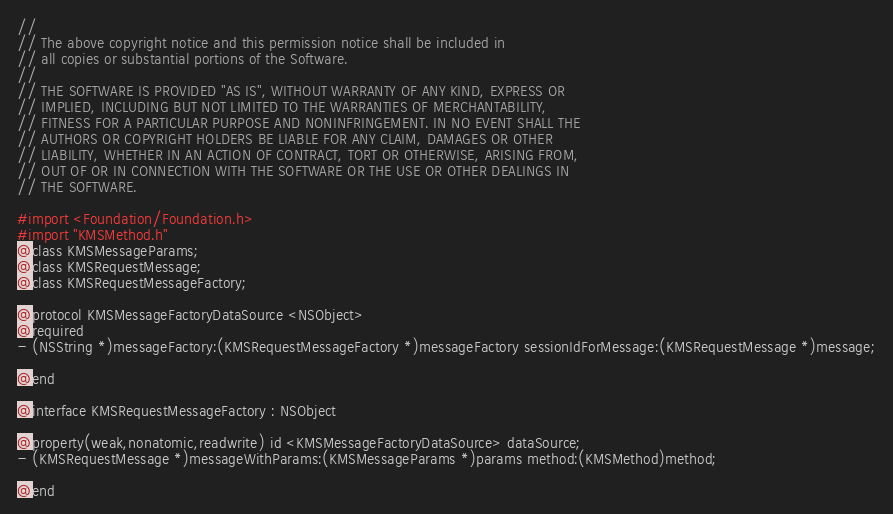<code> <loc_0><loc_0><loc_500><loc_500><_C_>//
// The above copyright notice and this permission notice shall be included in
// all copies or substantial portions of the Software.
//
// THE SOFTWARE IS PROVIDED "AS IS", WITHOUT WARRANTY OF ANY KIND, EXPRESS OR
// IMPLIED, INCLUDING BUT NOT LIMITED TO THE WARRANTIES OF MERCHANTABILITY,
// FITNESS FOR A PARTICULAR PURPOSE AND NONINFRINGEMENT. IN NO EVENT SHALL THE
// AUTHORS OR COPYRIGHT HOLDERS BE LIABLE FOR ANY CLAIM, DAMAGES OR OTHER
// LIABILITY, WHETHER IN AN ACTION OF CONTRACT, TORT OR OTHERWISE, ARISING FROM,
// OUT OF OR IN CONNECTION WITH THE SOFTWARE OR THE USE OR OTHER DEALINGS IN
// THE SOFTWARE.

#import <Foundation/Foundation.h>
#import "KMSMethod.h"
@class KMSMessageParams;
@class KMSRequestMessage;
@class KMSRequestMessageFactory;

@protocol KMSMessageFactoryDataSource <NSObject>
@required
- (NSString *)messageFactory:(KMSRequestMessageFactory *)messageFactory sessionIdForMessage:(KMSRequestMessage *)message;

@end

@interface KMSRequestMessageFactory : NSObject

@property(weak,nonatomic,readwrite) id <KMSMessageFactoryDataSource> dataSource;
- (KMSRequestMessage *)messageWithParams:(KMSMessageParams *)params method:(KMSMethod)method;

@end
</code> 